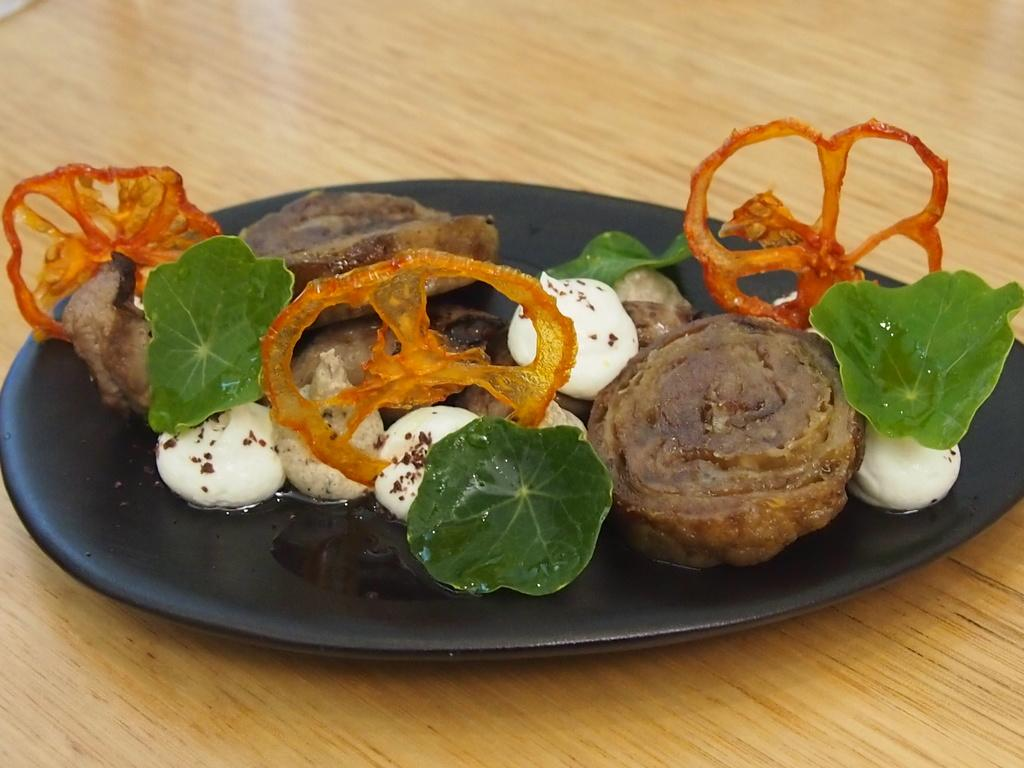What is on the plate in the image? There are food items on a plate in the image. Where is the plate located? The plate is on a table. What type of yarn is used to decorate the food items on the plate? There is no yarn present in the image, and the food items are not decorated with yarn. 